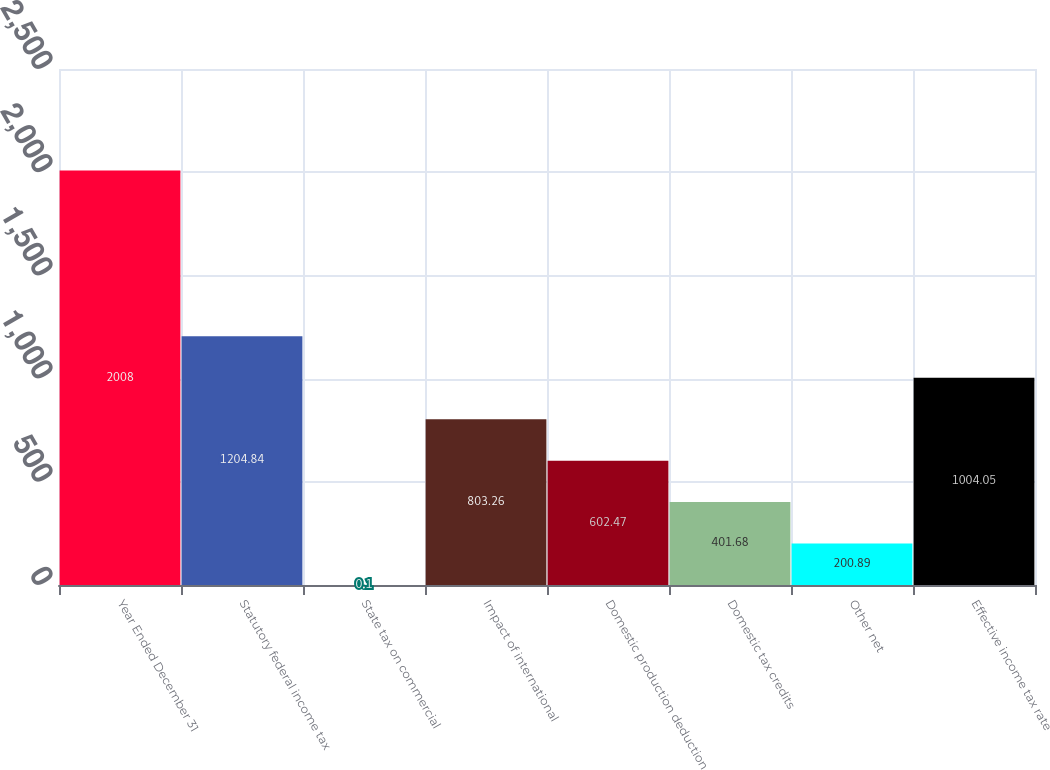Convert chart to OTSL. <chart><loc_0><loc_0><loc_500><loc_500><bar_chart><fcel>Year Ended December 31<fcel>Statutory federal income tax<fcel>State tax on commercial<fcel>Impact of international<fcel>Domestic production deduction<fcel>Domestic tax credits<fcel>Other net<fcel>Effective income tax rate<nl><fcel>2008<fcel>1204.84<fcel>0.1<fcel>803.26<fcel>602.47<fcel>401.68<fcel>200.89<fcel>1004.05<nl></chart> 